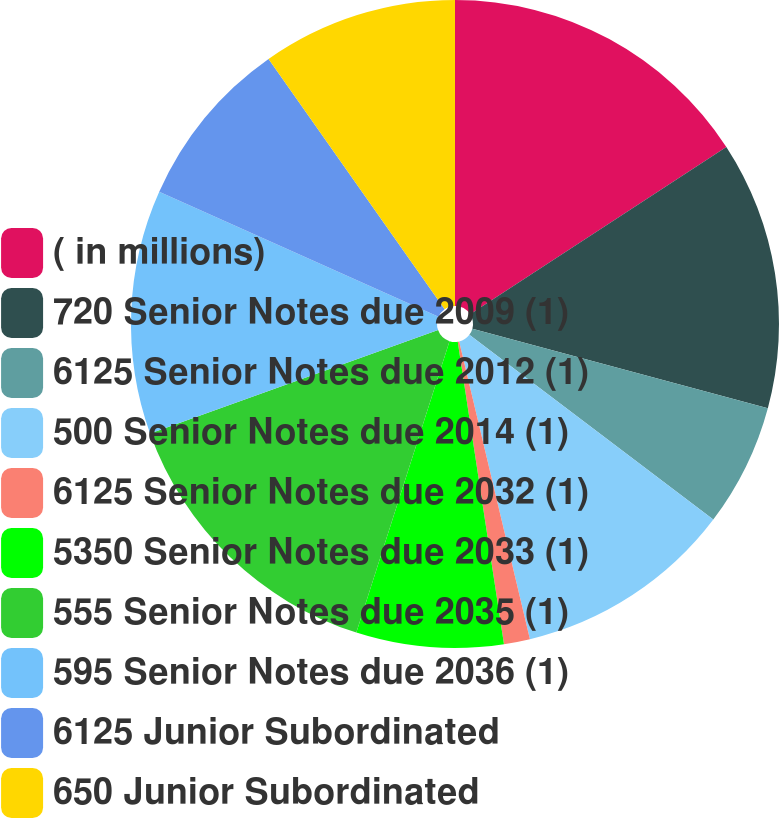<chart> <loc_0><loc_0><loc_500><loc_500><pie_chart><fcel>( in millions)<fcel>720 Senior Notes due 2009 (1)<fcel>6125 Senior Notes due 2012 (1)<fcel>500 Senior Notes due 2014 (1)<fcel>6125 Senior Notes due 2032 (1)<fcel>5350 Senior Notes due 2033 (1)<fcel>555 Senior Notes due 2035 (1)<fcel>595 Senior Notes due 2036 (1)<fcel>6125 Junior Subordinated<fcel>650 Junior Subordinated<nl><fcel>15.8%<fcel>13.39%<fcel>6.13%<fcel>10.97%<fcel>1.3%<fcel>7.34%<fcel>14.59%<fcel>12.18%<fcel>8.55%<fcel>9.76%<nl></chart> 